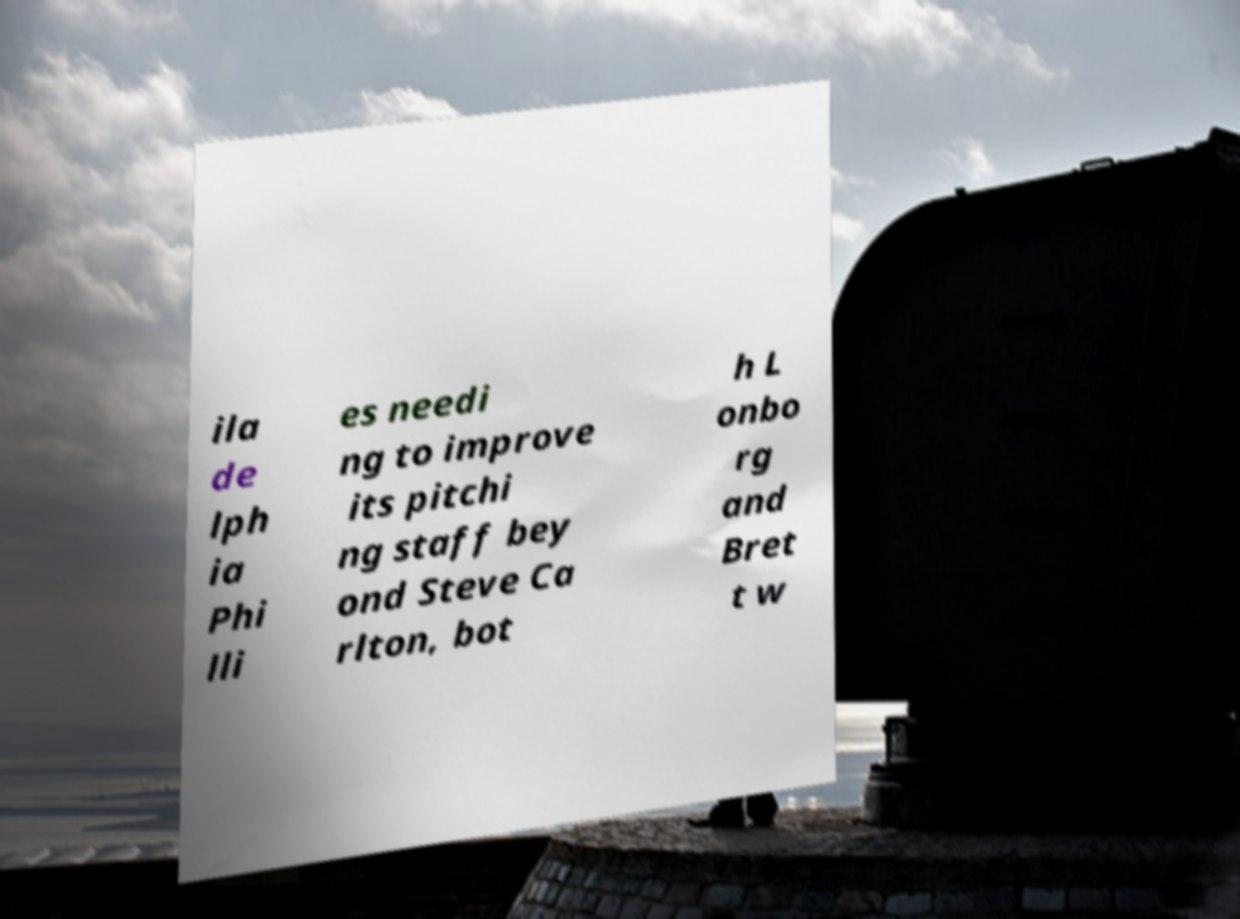What messages or text are displayed in this image? I need them in a readable, typed format. ila de lph ia Phi lli es needi ng to improve its pitchi ng staff bey ond Steve Ca rlton, bot h L onbo rg and Bret t w 